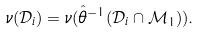Convert formula to latex. <formula><loc_0><loc_0><loc_500><loc_500>\nu ( \mathcal { D } _ { i } ) = \nu ( \hat { \theta } ^ { - 1 } ( \mathcal { D } _ { i } \cap \mathcal { M } _ { 1 } ) ) .</formula> 